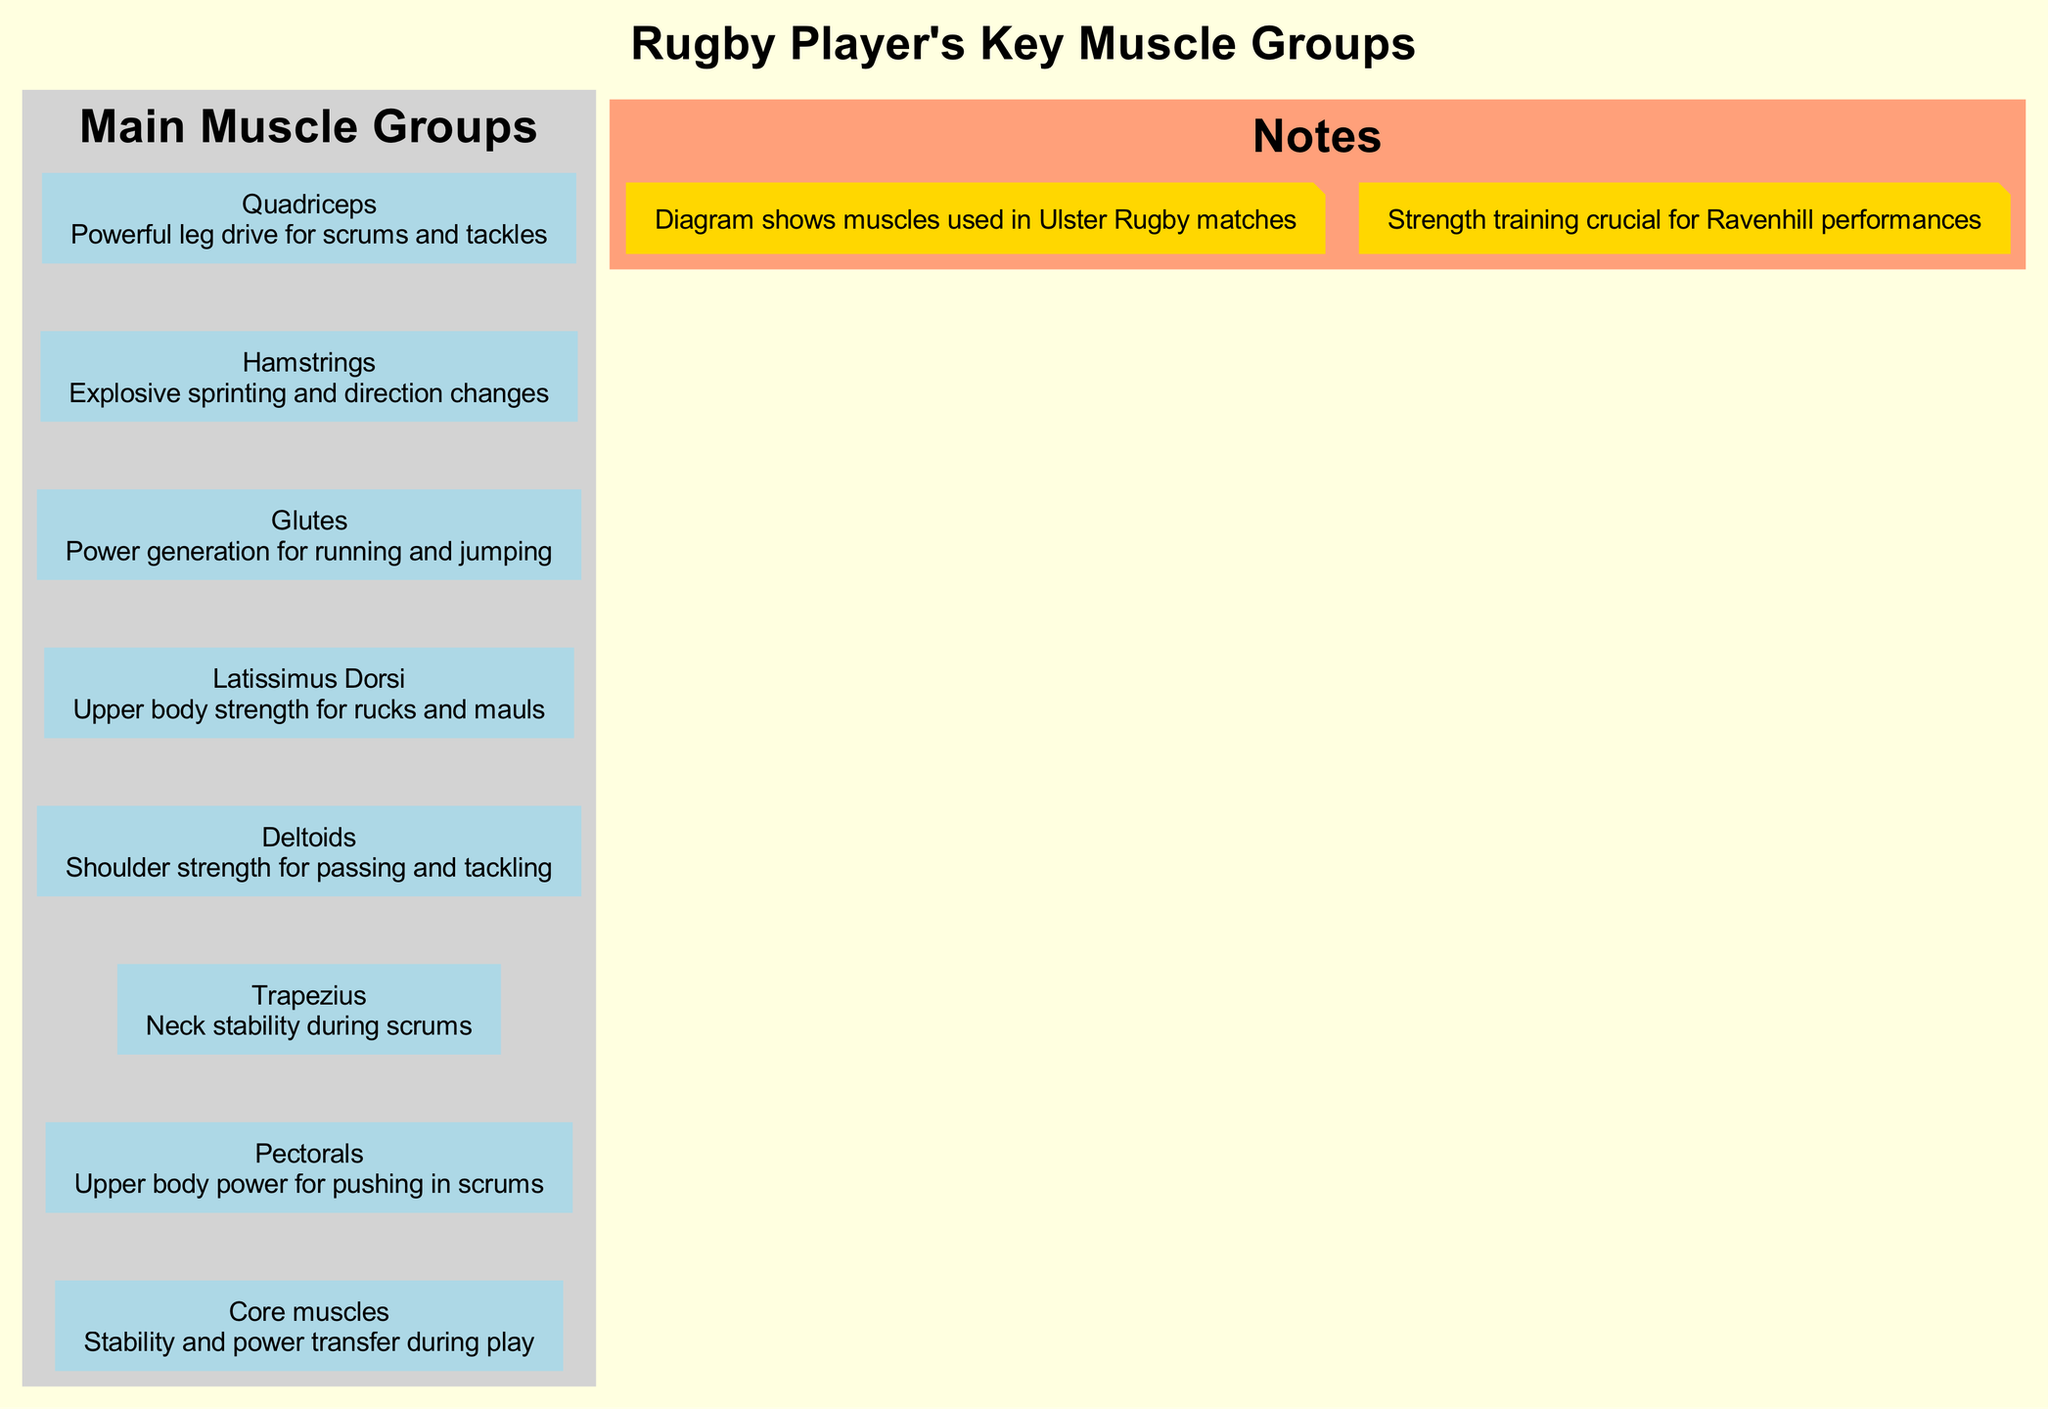What are the main muscle groups highlighted in the diagram? The diagram lists eight main muscle groups, which can be identified from the 'Main Muscle Groups' section. By counting the names listed, such as Quadriceps, Hamstrings, Glutes, etc., we find there are a total of eight.
Answer: Eight What function do the Glutes serve in rugby play? The diagram indicates that the Glutes are responsible for "Power generation for running and jumping." This description comes from the muscle's function stated alongside its name.
Answer: Power generation for running and jumping Which muscle group is associated with upper body strength in rucks? The diagram specifies the Latissimus Dorsi as providing "Upper body strength for rucks and mauls." This link is direct and explicitly states the role of this muscle group.
Answer: Latissimus Dorsi How many total notes are included in the diagram? The diagram features a 'Notes' section which includes two separate observations. By counting these notes, we see that there are two notes listed.
Answer: Two What is the function of the Core muscles as described in the diagram? According to the diagram, the function of the Core muscles is "Stability and power transfer during play." This phrase is presented clearly next to the Core muscles in the diagram.
Answer: Stability and power transfer during play Which muscle group contributes to shoulder strength for passing? The diagram shows that the Deltoids are related to "Shoulder strength for passing and tackling." This link is derived from the functional description provided for the Deltoids.
Answer: Deltoids Is there a direct relationship between the Quadriceps and Hamstrings in the diagram? The diagram includes an invisible edge connecting the Quadriceps to the Hamstrings. Even though it's not overtly visible, this connection signifies a direct relationship between these two muscle groups, implying they function together.
Answer: Yes Which muscle group aids in neck stability during scrums? The Trapezius is specifically described in the diagram as aiding "Neck stability during scrums," making it the muscle group focused on in scrums concerning neck stability.
Answer: Trapezius 